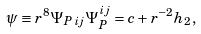Convert formula to latex. <formula><loc_0><loc_0><loc_500><loc_500>\psi \equiv r ^ { 8 } \Psi _ { P \, i j } \Psi _ { P } ^ { i j } = c + r ^ { - 2 } h _ { 2 } ,</formula> 